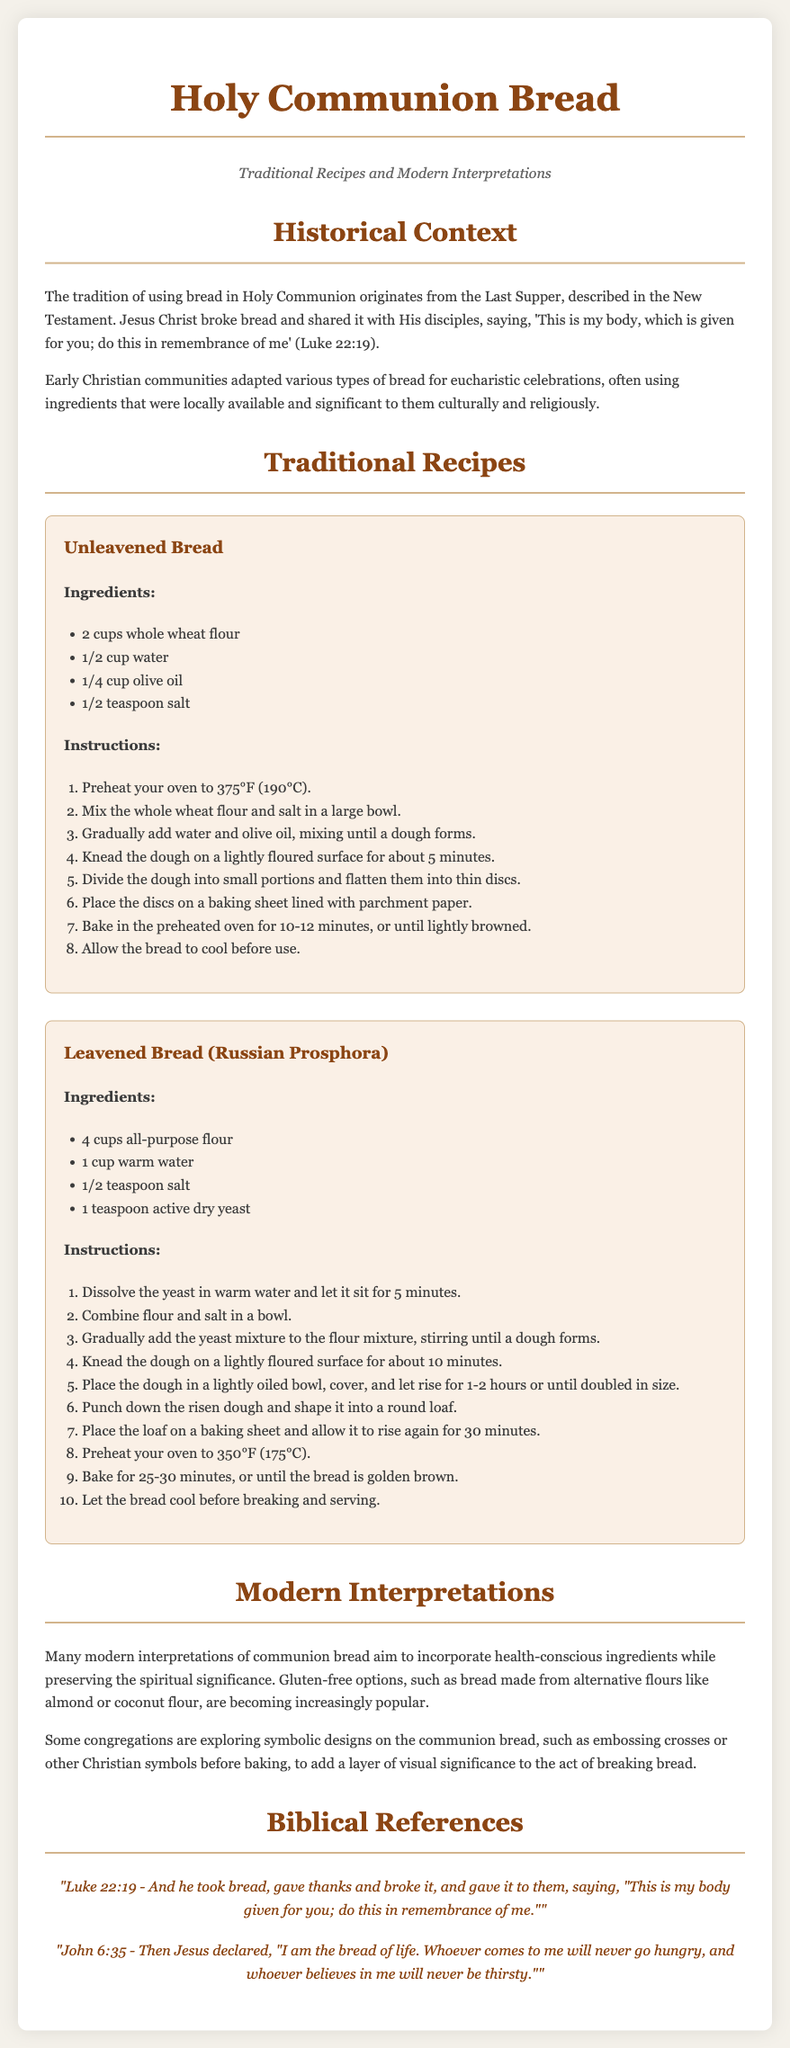What is the title of the document? The title of the document is given at the top of the rendered content, indicating its main subject.
Answer: Holy Communion Bread What is the main biblical reference mentioned in relation to communion bread? The document highlights a specific verse which connects to the tradition of communion bread from the New Testament.
Answer: Luke 22:19 How many ingredients are listed for Unleavened Bread? The ingredients for Unleavened Bread are listed in a bullet format, allowing the count to be easily determined.
Answer: 4 What is the baking temperature for leavened bread? The baking instructions specify a temperature for this particular type of communion bread.
Answer: 350°F Which type of flour is used in the Unleavened Bread recipe? The document specifies the type of flour in the ingredients section for Unleavened Bread.
Answer: Whole wheat flour What is a modern interpretation of communion bread mentioned in the document? The document suggests a health-conscious approach to communion bread and notes a specific alternative.
Answer: Gluten-free options How long should the dough for the leavened bread rise? The instructions for making leavened bread specify a rising time necessary for the dough.
Answer: 1-2 hours What are congregations exploring in modern communion bread designs? The document discusses creative expressions related to the appearance of communion bread in a contemporary context.
Answer: Symbolic designs What are two types of communion bread mentioned in the document? The document categorizes communion bread into types, offering traditional options for preparation.
Answer: Unleavened Bread and Leavened Bread (Russian Prosphora) 